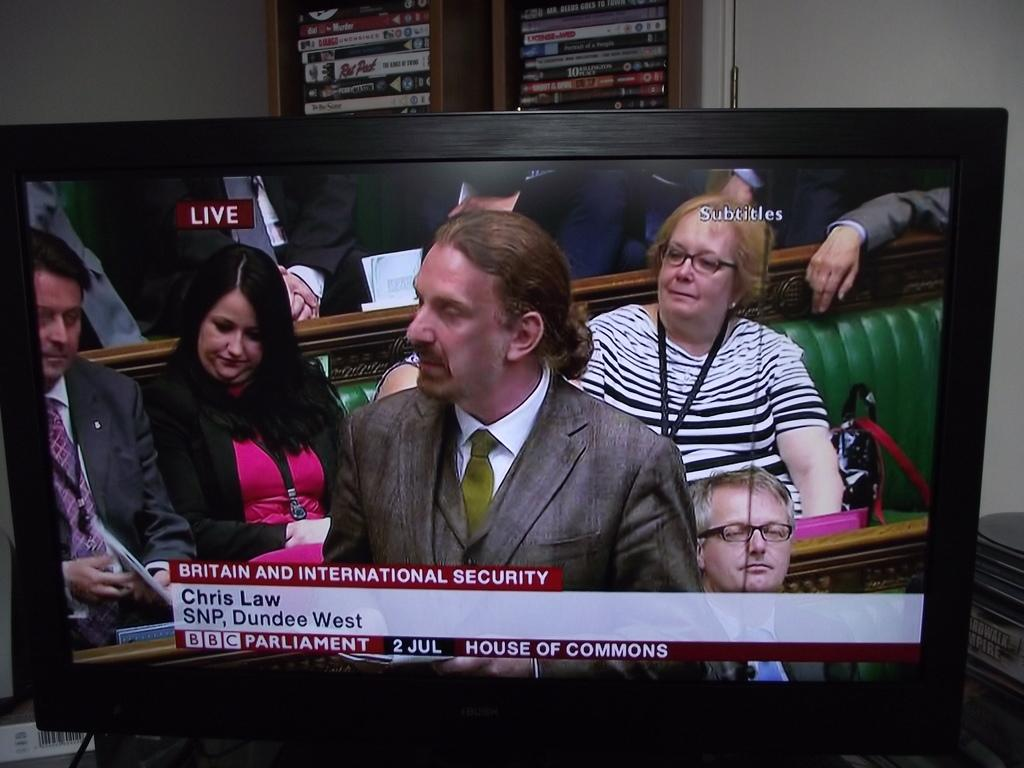<image>
Give a short and clear explanation of the subsequent image. A man on TV, Chris Law, is speaking on Britain and international security. 